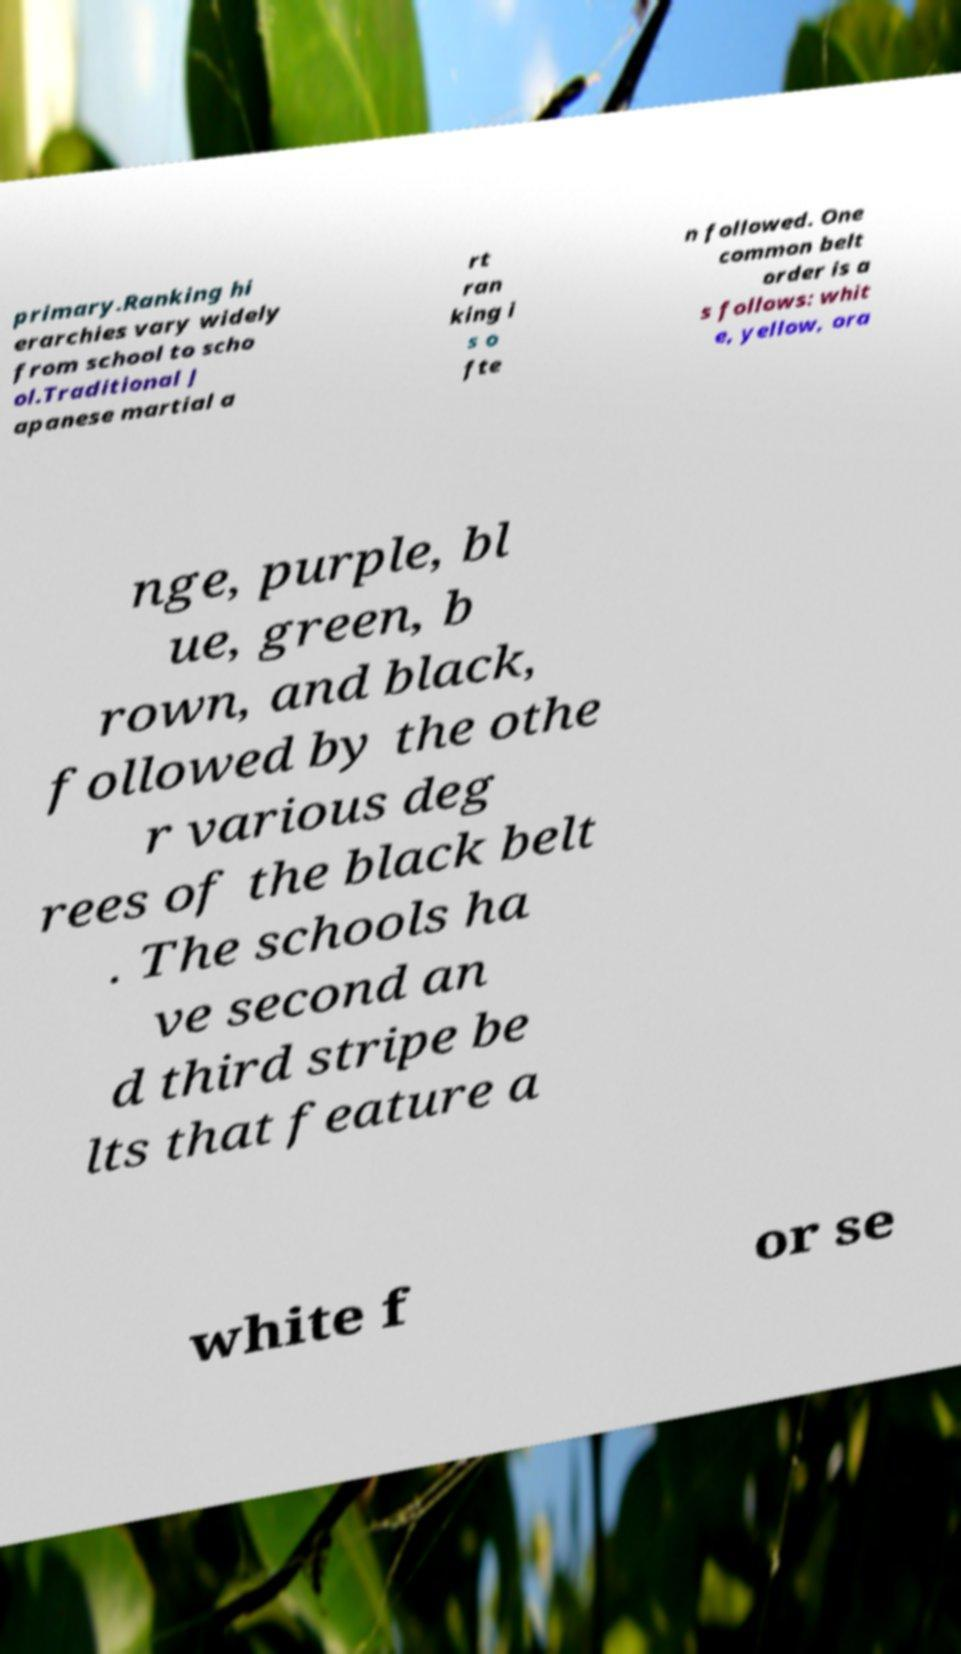I need the written content from this picture converted into text. Can you do that? primary.Ranking hi erarchies vary widely from school to scho ol.Traditional J apanese martial a rt ran king i s o fte n followed. One common belt order is a s follows: whit e, yellow, ora nge, purple, bl ue, green, b rown, and black, followed by the othe r various deg rees of the black belt . The schools ha ve second an d third stripe be lts that feature a white f or se 